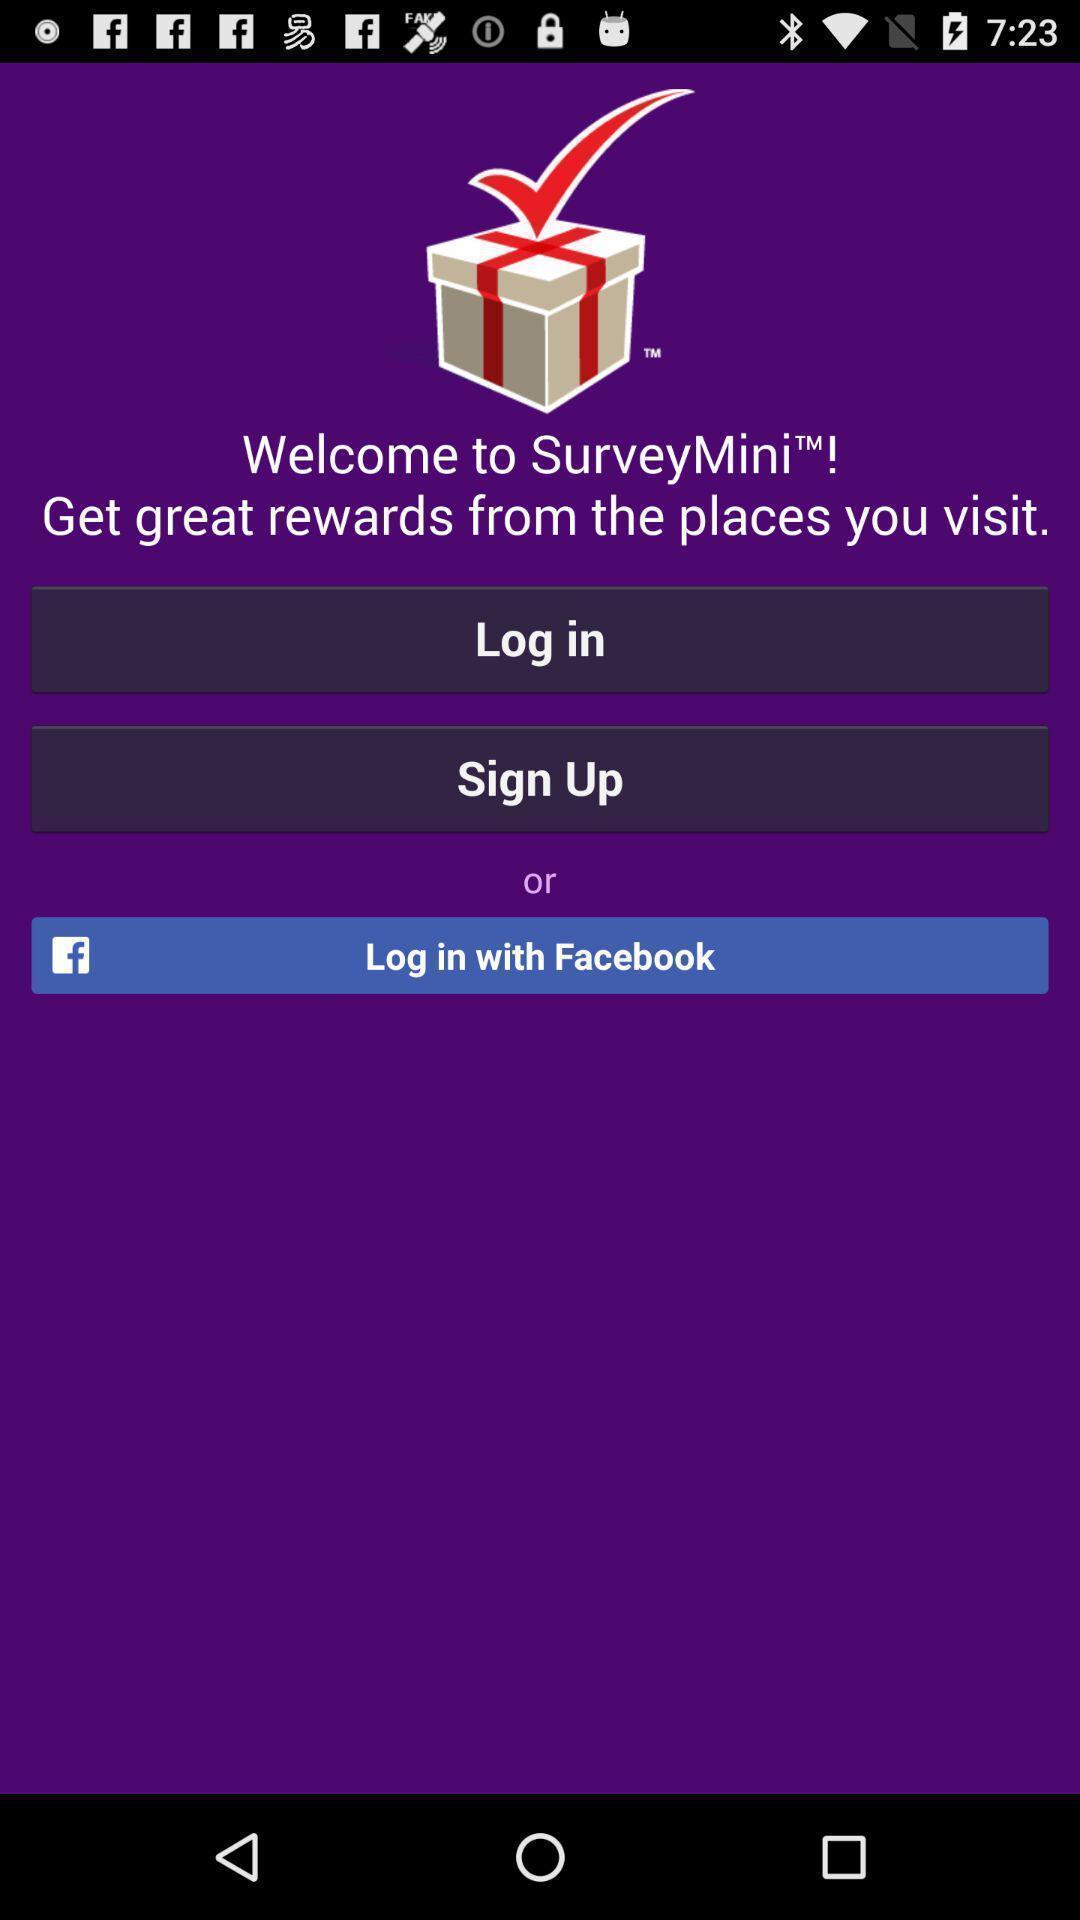Tell me about the visual elements in this screen capture. Sign up page. 